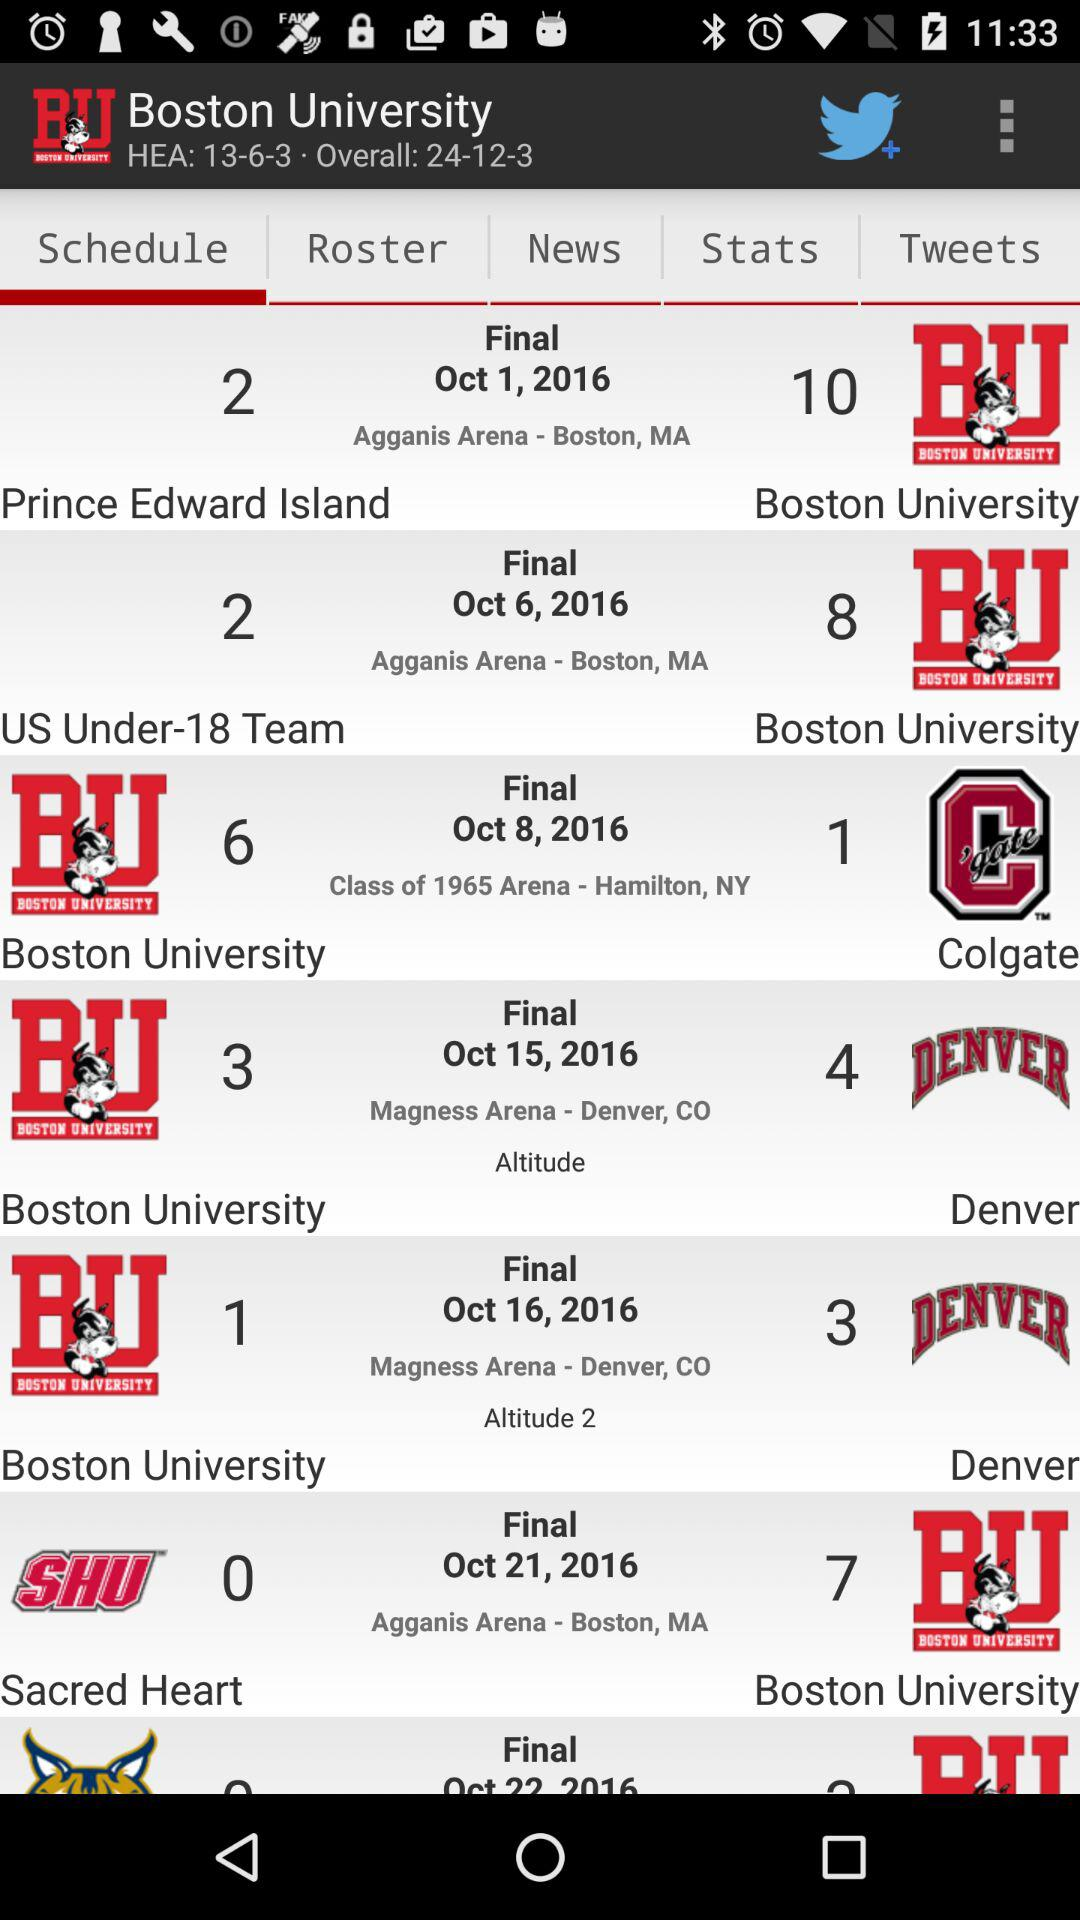What is the venue of the match for the "US Under-18 Team"? The venue of the match is Agganis Arena in Boston, MA. 